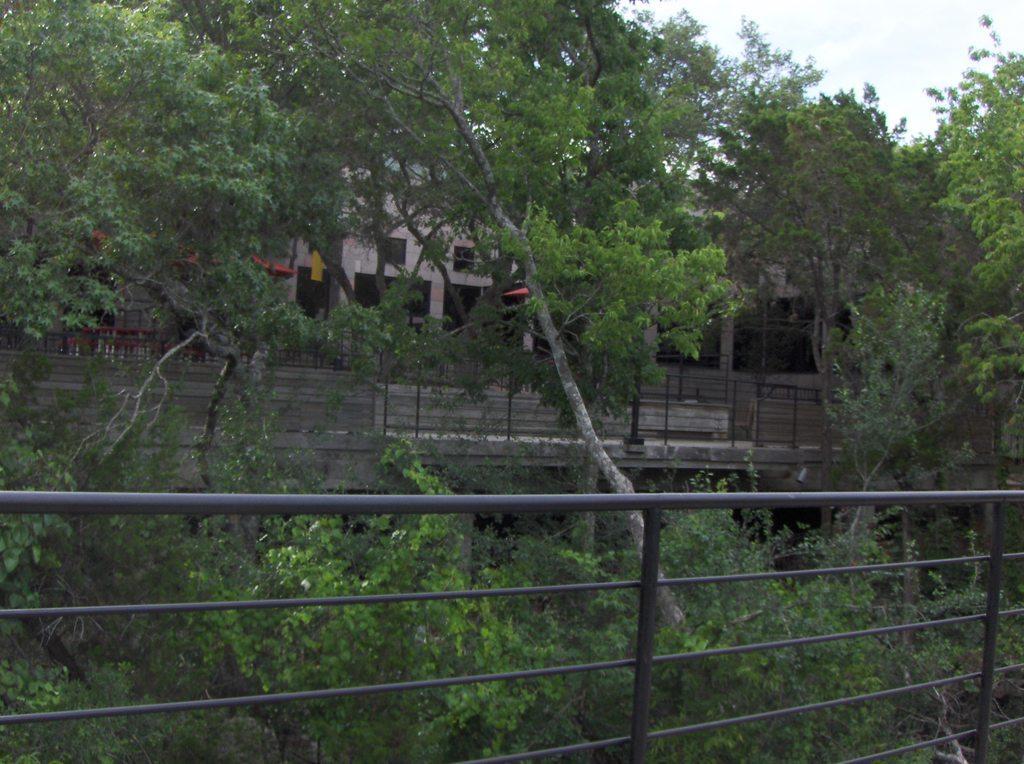Describe this image in one or two sentences. In the picture I can see steel railing, trees, houses, fence and the sky in the background. 